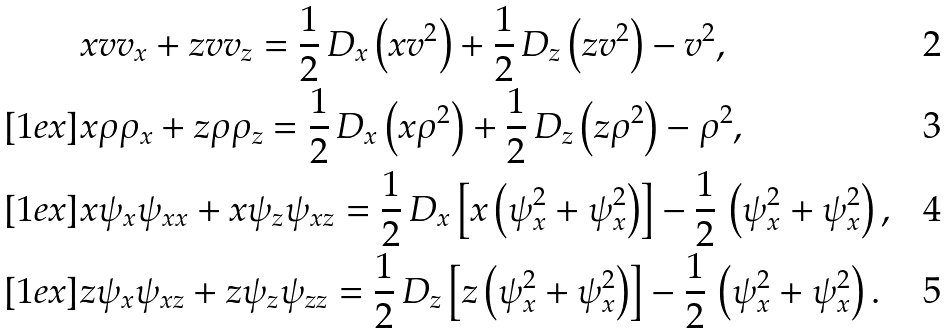<formula> <loc_0><loc_0><loc_500><loc_500>& x v v _ { x } + z v v _ { z } = \frac { 1 } { 2 } \, D _ { x } \left ( x v ^ { 2 } \right ) + \frac { 1 } { 2 } \, D _ { z } \left ( z v ^ { 2 } \right ) - v ^ { 2 } , \\ [ 1 e x ] & x \rho \rho _ { x } + z \rho \rho _ { z } = \frac { 1 } { 2 } \, D _ { x } \left ( x \rho ^ { 2 } \right ) + \frac { 1 } { 2 } \, D _ { z } \left ( z \rho ^ { 2 } \right ) - \rho ^ { 2 } , \\ [ 1 e x ] & x \psi _ { x } \psi _ { x x } + x \psi _ { z } \psi _ { x z } = \frac { 1 } { 2 } \, D _ { x } \left [ x \left ( \psi _ { x } ^ { 2 } + \psi _ { x } ^ { 2 } \right ) \right ] - \frac { 1 } { 2 } \, \left ( \psi _ { x } ^ { 2 } + \psi _ { x } ^ { 2 } \right ) , \\ [ 1 e x ] & z \psi _ { x } \psi _ { x z } + z \psi _ { z } \psi _ { z z } = \frac { 1 } { 2 } \, D _ { z } \left [ z \left ( \psi _ { x } ^ { 2 } + \psi _ { x } ^ { 2 } \right ) \right ] - \frac { 1 } { 2 } \, \left ( \psi _ { x } ^ { 2 } + \psi _ { x } ^ { 2 } \right ) .</formula> 